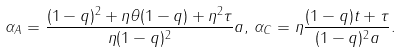<formula> <loc_0><loc_0><loc_500><loc_500>\alpha _ { A } = \frac { ( 1 - q ) ^ { 2 } + \eta \theta ( 1 - q ) + \eta ^ { 2 } \tau } { \eta ( 1 - q ) ^ { 2 } } a , \, \alpha _ { C } = \eta \frac { ( 1 - q ) t + \tau } { ( 1 - q ) ^ { 2 } a } .</formula> 